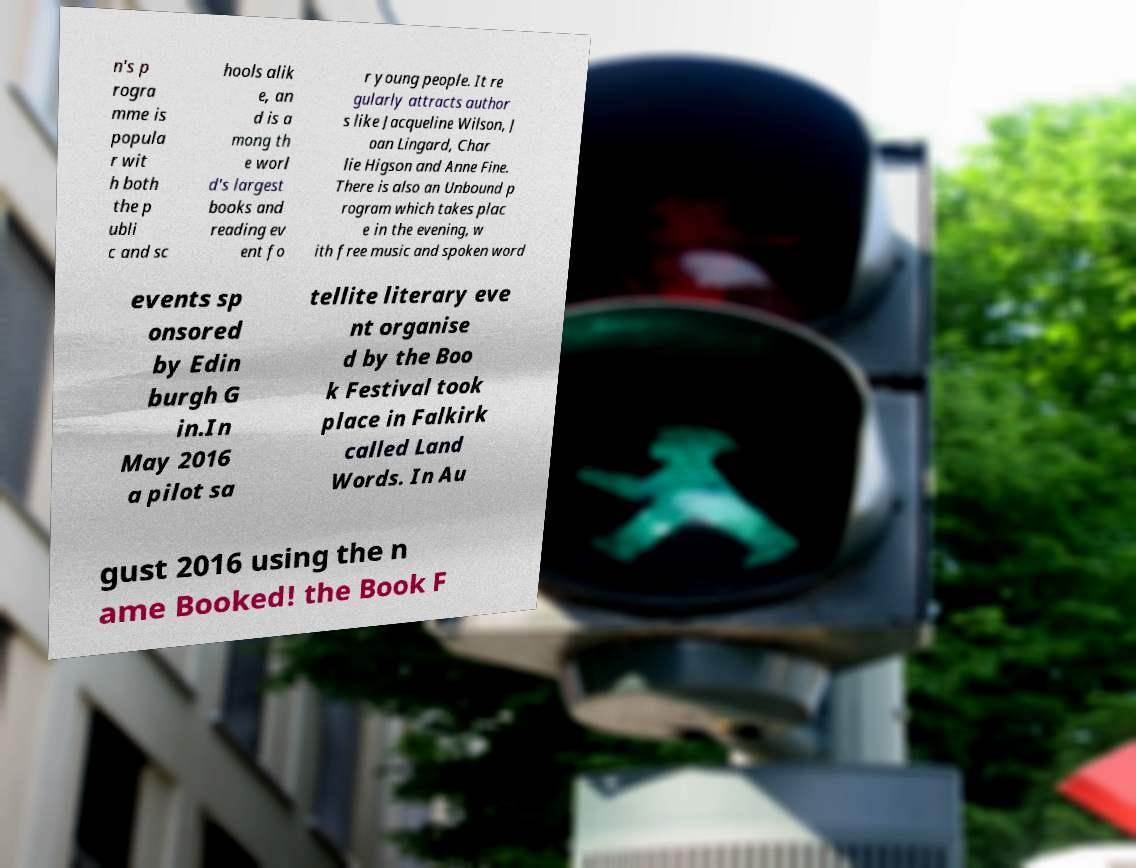There's text embedded in this image that I need extracted. Can you transcribe it verbatim? n's p rogra mme is popula r wit h both the p ubli c and sc hools alik e, an d is a mong th e worl d's largest books and reading ev ent fo r young people. It re gularly attracts author s like Jacqueline Wilson, J oan Lingard, Char lie Higson and Anne Fine. There is also an Unbound p rogram which takes plac e in the evening, w ith free music and spoken word events sp onsored by Edin burgh G in.In May 2016 a pilot sa tellite literary eve nt organise d by the Boo k Festival took place in Falkirk called Land Words. In Au gust 2016 using the n ame Booked! the Book F 